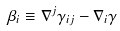Convert formula to latex. <formula><loc_0><loc_0><loc_500><loc_500>\beta _ { i } \equiv \nabla ^ { j } \gamma _ { i j } - \nabla _ { i } \gamma</formula> 